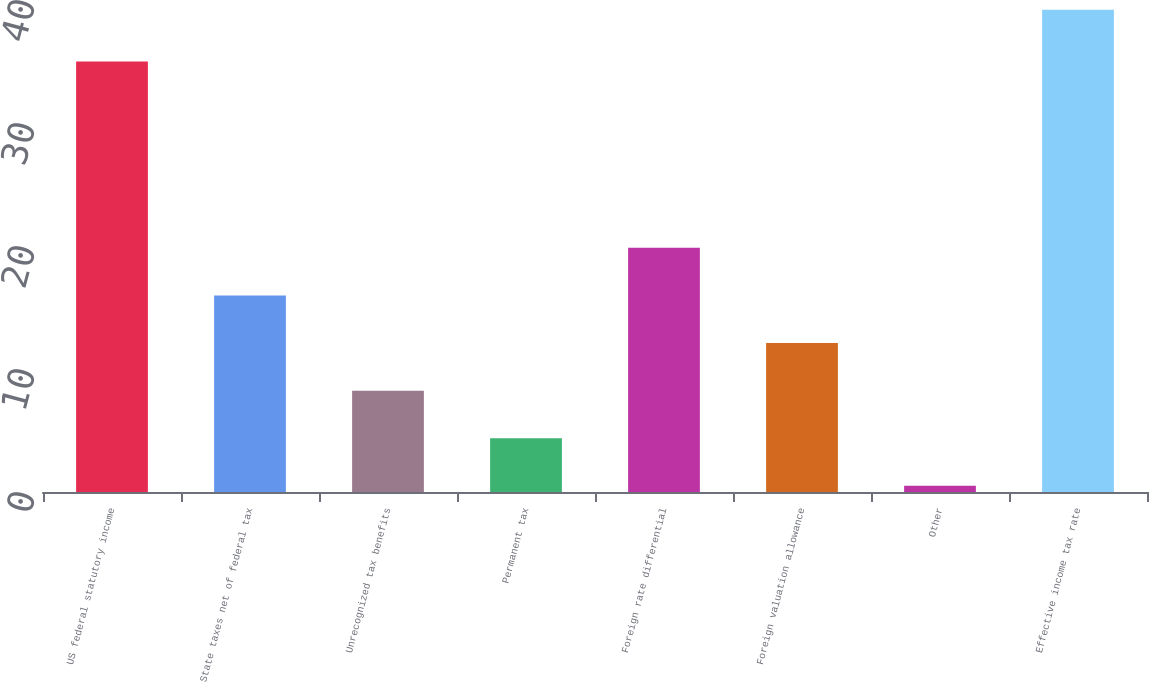Convert chart. <chart><loc_0><loc_0><loc_500><loc_500><bar_chart><fcel>US federal statutory income<fcel>State taxes net of federal tax<fcel>Unrecognized tax benefits<fcel>Permanent tax<fcel>Foreign rate differential<fcel>Foreign valuation allowance<fcel>Other<fcel>Effective income tax rate<nl><fcel>35<fcel>15.98<fcel>8.24<fcel>4.37<fcel>19.85<fcel>12.11<fcel>0.5<fcel>39.2<nl></chart> 